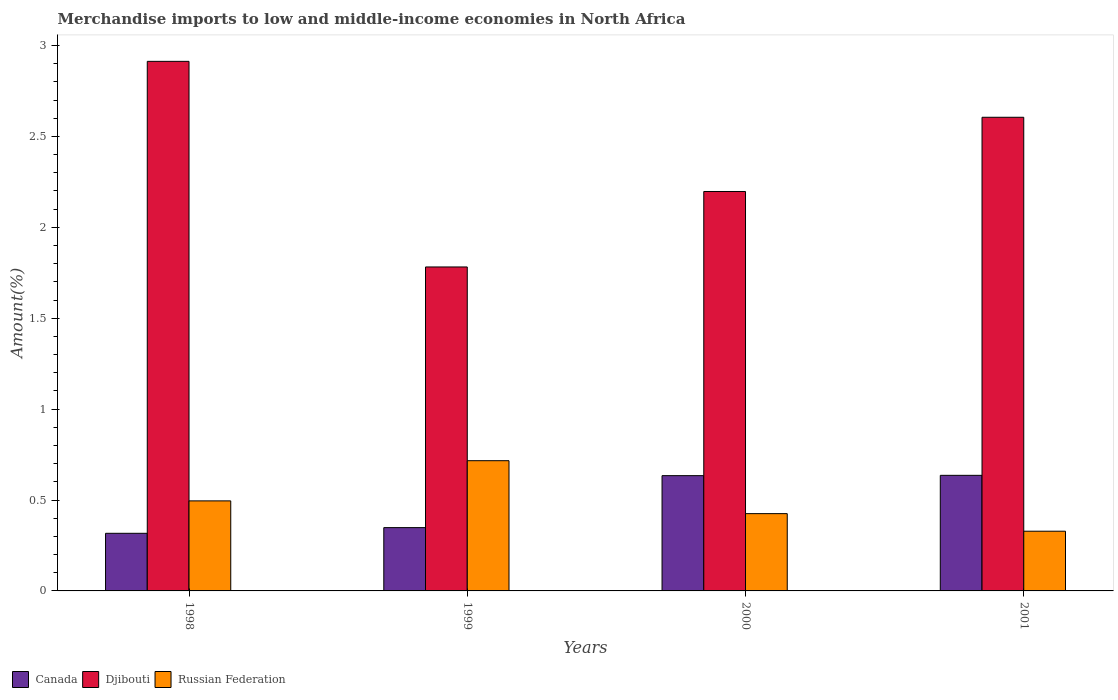How many groups of bars are there?
Provide a succinct answer. 4. Are the number of bars on each tick of the X-axis equal?
Provide a short and direct response. Yes. How many bars are there on the 1st tick from the left?
Your response must be concise. 3. How many bars are there on the 3rd tick from the right?
Give a very brief answer. 3. In how many cases, is the number of bars for a given year not equal to the number of legend labels?
Offer a very short reply. 0. What is the percentage of amount earned from merchandise imports in Djibouti in 2001?
Offer a very short reply. 2.61. Across all years, what is the maximum percentage of amount earned from merchandise imports in Djibouti?
Your response must be concise. 2.91. Across all years, what is the minimum percentage of amount earned from merchandise imports in Djibouti?
Provide a succinct answer. 1.78. In which year was the percentage of amount earned from merchandise imports in Canada maximum?
Your answer should be compact. 2001. In which year was the percentage of amount earned from merchandise imports in Canada minimum?
Make the answer very short. 1998. What is the total percentage of amount earned from merchandise imports in Russian Federation in the graph?
Make the answer very short. 1.96. What is the difference between the percentage of amount earned from merchandise imports in Russian Federation in 1999 and that in 2001?
Your response must be concise. 0.39. What is the difference between the percentage of amount earned from merchandise imports in Djibouti in 1998 and the percentage of amount earned from merchandise imports in Russian Federation in 2001?
Ensure brevity in your answer.  2.58. What is the average percentage of amount earned from merchandise imports in Canada per year?
Make the answer very short. 0.48. In the year 2000, what is the difference between the percentage of amount earned from merchandise imports in Djibouti and percentage of amount earned from merchandise imports in Canada?
Make the answer very short. 1.56. In how many years, is the percentage of amount earned from merchandise imports in Russian Federation greater than 0.1 %?
Your answer should be compact. 4. What is the ratio of the percentage of amount earned from merchandise imports in Djibouti in 1999 to that in 2001?
Make the answer very short. 0.68. Is the difference between the percentage of amount earned from merchandise imports in Djibouti in 2000 and 2001 greater than the difference between the percentage of amount earned from merchandise imports in Canada in 2000 and 2001?
Offer a terse response. No. What is the difference between the highest and the second highest percentage of amount earned from merchandise imports in Canada?
Ensure brevity in your answer.  0. What is the difference between the highest and the lowest percentage of amount earned from merchandise imports in Russian Federation?
Your answer should be compact. 0.39. What does the 1st bar from the left in 2000 represents?
Your answer should be very brief. Canada. What does the 1st bar from the right in 2001 represents?
Your answer should be very brief. Russian Federation. How many years are there in the graph?
Make the answer very short. 4. What is the difference between two consecutive major ticks on the Y-axis?
Your answer should be compact. 0.5. Are the values on the major ticks of Y-axis written in scientific E-notation?
Provide a short and direct response. No. Does the graph contain grids?
Provide a short and direct response. No. Where does the legend appear in the graph?
Your response must be concise. Bottom left. How many legend labels are there?
Offer a terse response. 3. What is the title of the graph?
Give a very brief answer. Merchandise imports to low and middle-income economies in North Africa. What is the label or title of the X-axis?
Ensure brevity in your answer.  Years. What is the label or title of the Y-axis?
Ensure brevity in your answer.  Amount(%). What is the Amount(%) of Canada in 1998?
Provide a short and direct response. 0.32. What is the Amount(%) of Djibouti in 1998?
Ensure brevity in your answer.  2.91. What is the Amount(%) of Russian Federation in 1998?
Provide a short and direct response. 0.5. What is the Amount(%) of Canada in 1999?
Keep it short and to the point. 0.35. What is the Amount(%) of Djibouti in 1999?
Your answer should be compact. 1.78. What is the Amount(%) in Russian Federation in 1999?
Provide a short and direct response. 0.72. What is the Amount(%) in Canada in 2000?
Offer a very short reply. 0.63. What is the Amount(%) of Djibouti in 2000?
Provide a short and direct response. 2.2. What is the Amount(%) of Russian Federation in 2000?
Ensure brevity in your answer.  0.43. What is the Amount(%) of Canada in 2001?
Make the answer very short. 0.64. What is the Amount(%) in Djibouti in 2001?
Ensure brevity in your answer.  2.61. What is the Amount(%) of Russian Federation in 2001?
Make the answer very short. 0.33. Across all years, what is the maximum Amount(%) in Canada?
Your response must be concise. 0.64. Across all years, what is the maximum Amount(%) in Djibouti?
Your response must be concise. 2.91. Across all years, what is the maximum Amount(%) of Russian Federation?
Provide a succinct answer. 0.72. Across all years, what is the minimum Amount(%) of Canada?
Give a very brief answer. 0.32. Across all years, what is the minimum Amount(%) in Djibouti?
Give a very brief answer. 1.78. Across all years, what is the minimum Amount(%) in Russian Federation?
Your response must be concise. 0.33. What is the total Amount(%) in Canada in the graph?
Your answer should be compact. 1.93. What is the total Amount(%) of Djibouti in the graph?
Ensure brevity in your answer.  9.5. What is the total Amount(%) of Russian Federation in the graph?
Offer a very short reply. 1.96. What is the difference between the Amount(%) in Canada in 1998 and that in 1999?
Provide a succinct answer. -0.03. What is the difference between the Amount(%) in Djibouti in 1998 and that in 1999?
Your answer should be compact. 1.13. What is the difference between the Amount(%) of Russian Federation in 1998 and that in 1999?
Your response must be concise. -0.22. What is the difference between the Amount(%) of Canada in 1998 and that in 2000?
Ensure brevity in your answer.  -0.32. What is the difference between the Amount(%) in Djibouti in 1998 and that in 2000?
Give a very brief answer. 0.72. What is the difference between the Amount(%) of Russian Federation in 1998 and that in 2000?
Your response must be concise. 0.07. What is the difference between the Amount(%) in Canada in 1998 and that in 2001?
Your answer should be very brief. -0.32. What is the difference between the Amount(%) of Djibouti in 1998 and that in 2001?
Make the answer very short. 0.31. What is the difference between the Amount(%) of Russian Federation in 1998 and that in 2001?
Provide a short and direct response. 0.17. What is the difference between the Amount(%) of Canada in 1999 and that in 2000?
Your answer should be compact. -0.29. What is the difference between the Amount(%) in Djibouti in 1999 and that in 2000?
Your response must be concise. -0.42. What is the difference between the Amount(%) in Russian Federation in 1999 and that in 2000?
Ensure brevity in your answer.  0.29. What is the difference between the Amount(%) of Canada in 1999 and that in 2001?
Keep it short and to the point. -0.29. What is the difference between the Amount(%) of Djibouti in 1999 and that in 2001?
Your answer should be very brief. -0.82. What is the difference between the Amount(%) in Russian Federation in 1999 and that in 2001?
Your response must be concise. 0.39. What is the difference between the Amount(%) in Canada in 2000 and that in 2001?
Offer a terse response. -0. What is the difference between the Amount(%) of Djibouti in 2000 and that in 2001?
Provide a succinct answer. -0.41. What is the difference between the Amount(%) in Russian Federation in 2000 and that in 2001?
Provide a succinct answer. 0.1. What is the difference between the Amount(%) of Canada in 1998 and the Amount(%) of Djibouti in 1999?
Keep it short and to the point. -1.46. What is the difference between the Amount(%) in Canada in 1998 and the Amount(%) in Russian Federation in 1999?
Provide a succinct answer. -0.4. What is the difference between the Amount(%) in Djibouti in 1998 and the Amount(%) in Russian Federation in 1999?
Your answer should be compact. 2.2. What is the difference between the Amount(%) of Canada in 1998 and the Amount(%) of Djibouti in 2000?
Give a very brief answer. -1.88. What is the difference between the Amount(%) in Canada in 1998 and the Amount(%) in Russian Federation in 2000?
Keep it short and to the point. -0.11. What is the difference between the Amount(%) of Djibouti in 1998 and the Amount(%) of Russian Federation in 2000?
Your answer should be compact. 2.49. What is the difference between the Amount(%) of Canada in 1998 and the Amount(%) of Djibouti in 2001?
Give a very brief answer. -2.29. What is the difference between the Amount(%) of Canada in 1998 and the Amount(%) of Russian Federation in 2001?
Keep it short and to the point. -0.01. What is the difference between the Amount(%) of Djibouti in 1998 and the Amount(%) of Russian Federation in 2001?
Offer a very short reply. 2.58. What is the difference between the Amount(%) in Canada in 1999 and the Amount(%) in Djibouti in 2000?
Your answer should be compact. -1.85. What is the difference between the Amount(%) of Canada in 1999 and the Amount(%) of Russian Federation in 2000?
Ensure brevity in your answer.  -0.08. What is the difference between the Amount(%) of Djibouti in 1999 and the Amount(%) of Russian Federation in 2000?
Make the answer very short. 1.36. What is the difference between the Amount(%) in Canada in 1999 and the Amount(%) in Djibouti in 2001?
Ensure brevity in your answer.  -2.26. What is the difference between the Amount(%) of Canada in 1999 and the Amount(%) of Russian Federation in 2001?
Make the answer very short. 0.02. What is the difference between the Amount(%) of Djibouti in 1999 and the Amount(%) of Russian Federation in 2001?
Offer a terse response. 1.45. What is the difference between the Amount(%) of Canada in 2000 and the Amount(%) of Djibouti in 2001?
Offer a terse response. -1.97. What is the difference between the Amount(%) in Canada in 2000 and the Amount(%) in Russian Federation in 2001?
Your answer should be compact. 0.31. What is the difference between the Amount(%) of Djibouti in 2000 and the Amount(%) of Russian Federation in 2001?
Provide a short and direct response. 1.87. What is the average Amount(%) of Canada per year?
Keep it short and to the point. 0.48. What is the average Amount(%) of Djibouti per year?
Offer a very short reply. 2.37. What is the average Amount(%) of Russian Federation per year?
Keep it short and to the point. 0.49. In the year 1998, what is the difference between the Amount(%) in Canada and Amount(%) in Djibouti?
Offer a very short reply. -2.6. In the year 1998, what is the difference between the Amount(%) in Canada and Amount(%) in Russian Federation?
Offer a very short reply. -0.18. In the year 1998, what is the difference between the Amount(%) in Djibouti and Amount(%) in Russian Federation?
Make the answer very short. 2.42. In the year 1999, what is the difference between the Amount(%) in Canada and Amount(%) in Djibouti?
Keep it short and to the point. -1.43. In the year 1999, what is the difference between the Amount(%) of Canada and Amount(%) of Russian Federation?
Your answer should be very brief. -0.37. In the year 1999, what is the difference between the Amount(%) of Djibouti and Amount(%) of Russian Federation?
Your answer should be very brief. 1.07. In the year 2000, what is the difference between the Amount(%) in Canada and Amount(%) in Djibouti?
Offer a very short reply. -1.56. In the year 2000, what is the difference between the Amount(%) in Canada and Amount(%) in Russian Federation?
Your answer should be compact. 0.21. In the year 2000, what is the difference between the Amount(%) of Djibouti and Amount(%) of Russian Federation?
Your response must be concise. 1.77. In the year 2001, what is the difference between the Amount(%) of Canada and Amount(%) of Djibouti?
Your answer should be very brief. -1.97. In the year 2001, what is the difference between the Amount(%) in Canada and Amount(%) in Russian Federation?
Ensure brevity in your answer.  0.31. In the year 2001, what is the difference between the Amount(%) in Djibouti and Amount(%) in Russian Federation?
Your answer should be compact. 2.28. What is the ratio of the Amount(%) in Canada in 1998 to that in 1999?
Provide a succinct answer. 0.91. What is the ratio of the Amount(%) in Djibouti in 1998 to that in 1999?
Your answer should be compact. 1.63. What is the ratio of the Amount(%) of Russian Federation in 1998 to that in 1999?
Your response must be concise. 0.69. What is the ratio of the Amount(%) of Canada in 1998 to that in 2000?
Ensure brevity in your answer.  0.5. What is the ratio of the Amount(%) of Djibouti in 1998 to that in 2000?
Provide a short and direct response. 1.33. What is the ratio of the Amount(%) in Russian Federation in 1998 to that in 2000?
Offer a terse response. 1.17. What is the ratio of the Amount(%) in Canada in 1998 to that in 2001?
Provide a succinct answer. 0.5. What is the ratio of the Amount(%) of Djibouti in 1998 to that in 2001?
Offer a very short reply. 1.12. What is the ratio of the Amount(%) of Russian Federation in 1998 to that in 2001?
Keep it short and to the point. 1.51. What is the ratio of the Amount(%) in Canada in 1999 to that in 2000?
Keep it short and to the point. 0.55. What is the ratio of the Amount(%) of Djibouti in 1999 to that in 2000?
Your answer should be very brief. 0.81. What is the ratio of the Amount(%) in Russian Federation in 1999 to that in 2000?
Provide a short and direct response. 1.68. What is the ratio of the Amount(%) of Canada in 1999 to that in 2001?
Provide a succinct answer. 0.55. What is the ratio of the Amount(%) of Djibouti in 1999 to that in 2001?
Your answer should be very brief. 0.68. What is the ratio of the Amount(%) of Russian Federation in 1999 to that in 2001?
Your answer should be compact. 2.18. What is the ratio of the Amount(%) in Djibouti in 2000 to that in 2001?
Ensure brevity in your answer.  0.84. What is the ratio of the Amount(%) in Russian Federation in 2000 to that in 2001?
Your answer should be compact. 1.29. What is the difference between the highest and the second highest Amount(%) in Canada?
Offer a very short reply. 0. What is the difference between the highest and the second highest Amount(%) of Djibouti?
Provide a succinct answer. 0.31. What is the difference between the highest and the second highest Amount(%) of Russian Federation?
Offer a terse response. 0.22. What is the difference between the highest and the lowest Amount(%) of Canada?
Your response must be concise. 0.32. What is the difference between the highest and the lowest Amount(%) in Djibouti?
Provide a short and direct response. 1.13. What is the difference between the highest and the lowest Amount(%) in Russian Federation?
Keep it short and to the point. 0.39. 